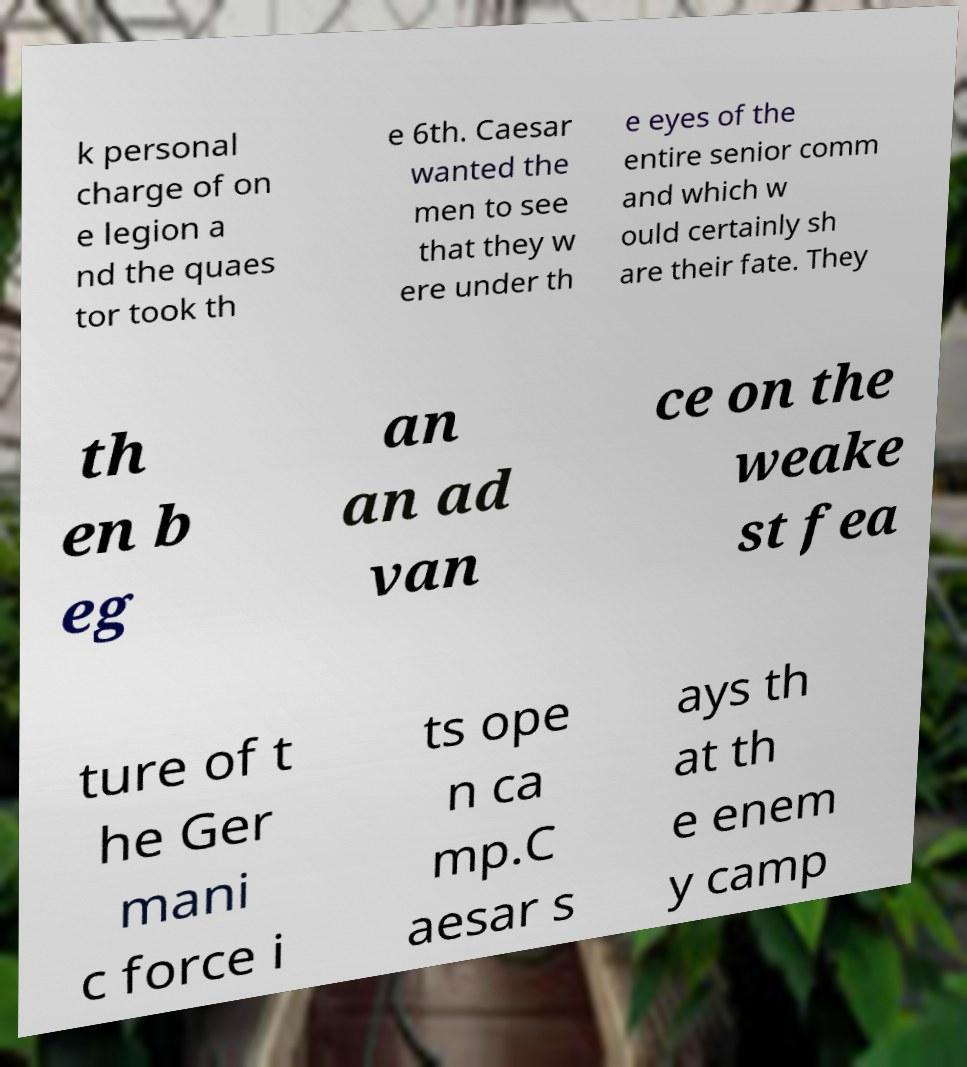Could you extract and type out the text from this image? k personal charge of on e legion a nd the quaes tor took th e 6th. Caesar wanted the men to see that they w ere under th e eyes of the entire senior comm and which w ould certainly sh are their fate. They th en b eg an an ad van ce on the weake st fea ture of t he Ger mani c force i ts ope n ca mp.C aesar s ays th at th e enem y camp 